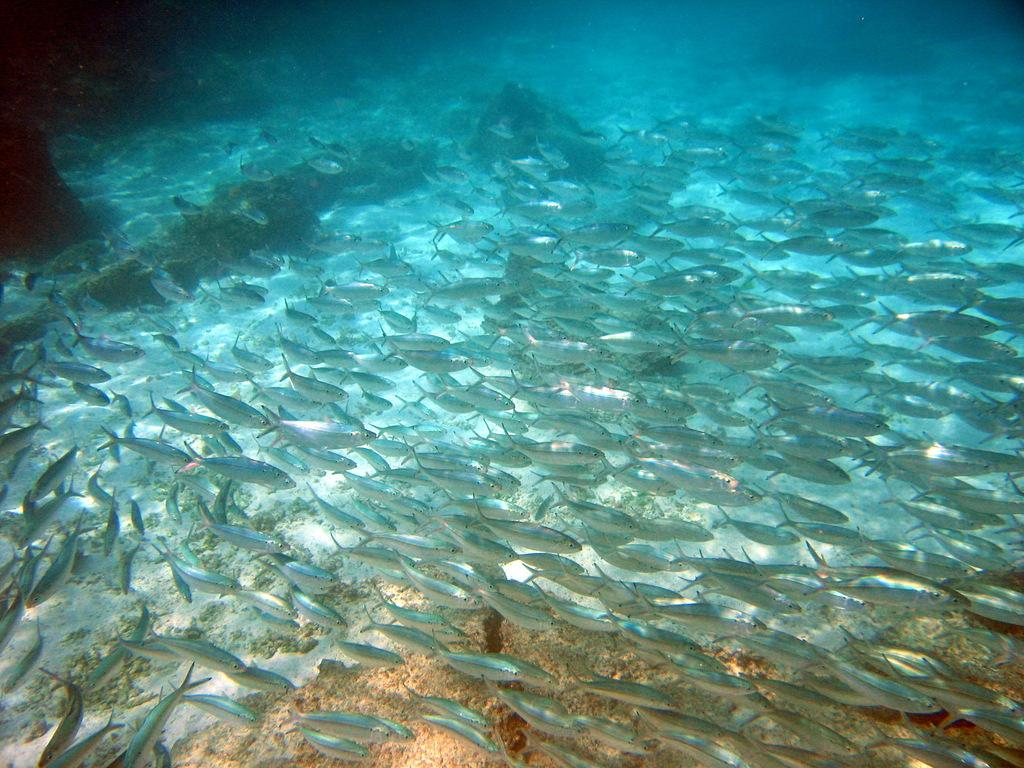What type of animals can be seen in the image? Fish can be seen in the water. What else can be observed in the image besides the fish? There are other objects in the image. What type of crops is the farmer growing on the land in the image? There is no farmer or land present in the image; it features fish in the water and other objects. What type of sail can be seen on the boat in the image? There is no boat or sail present in the image. 